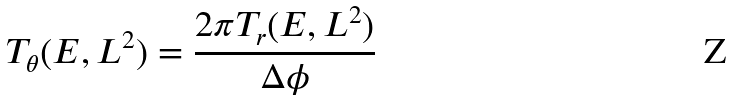Convert formula to latex. <formula><loc_0><loc_0><loc_500><loc_500>T _ { \theta } ( E , L ^ { 2 } ) = \frac { 2 \pi T _ { r } ( E , L ^ { 2 } ) } { \Delta \phi }</formula> 